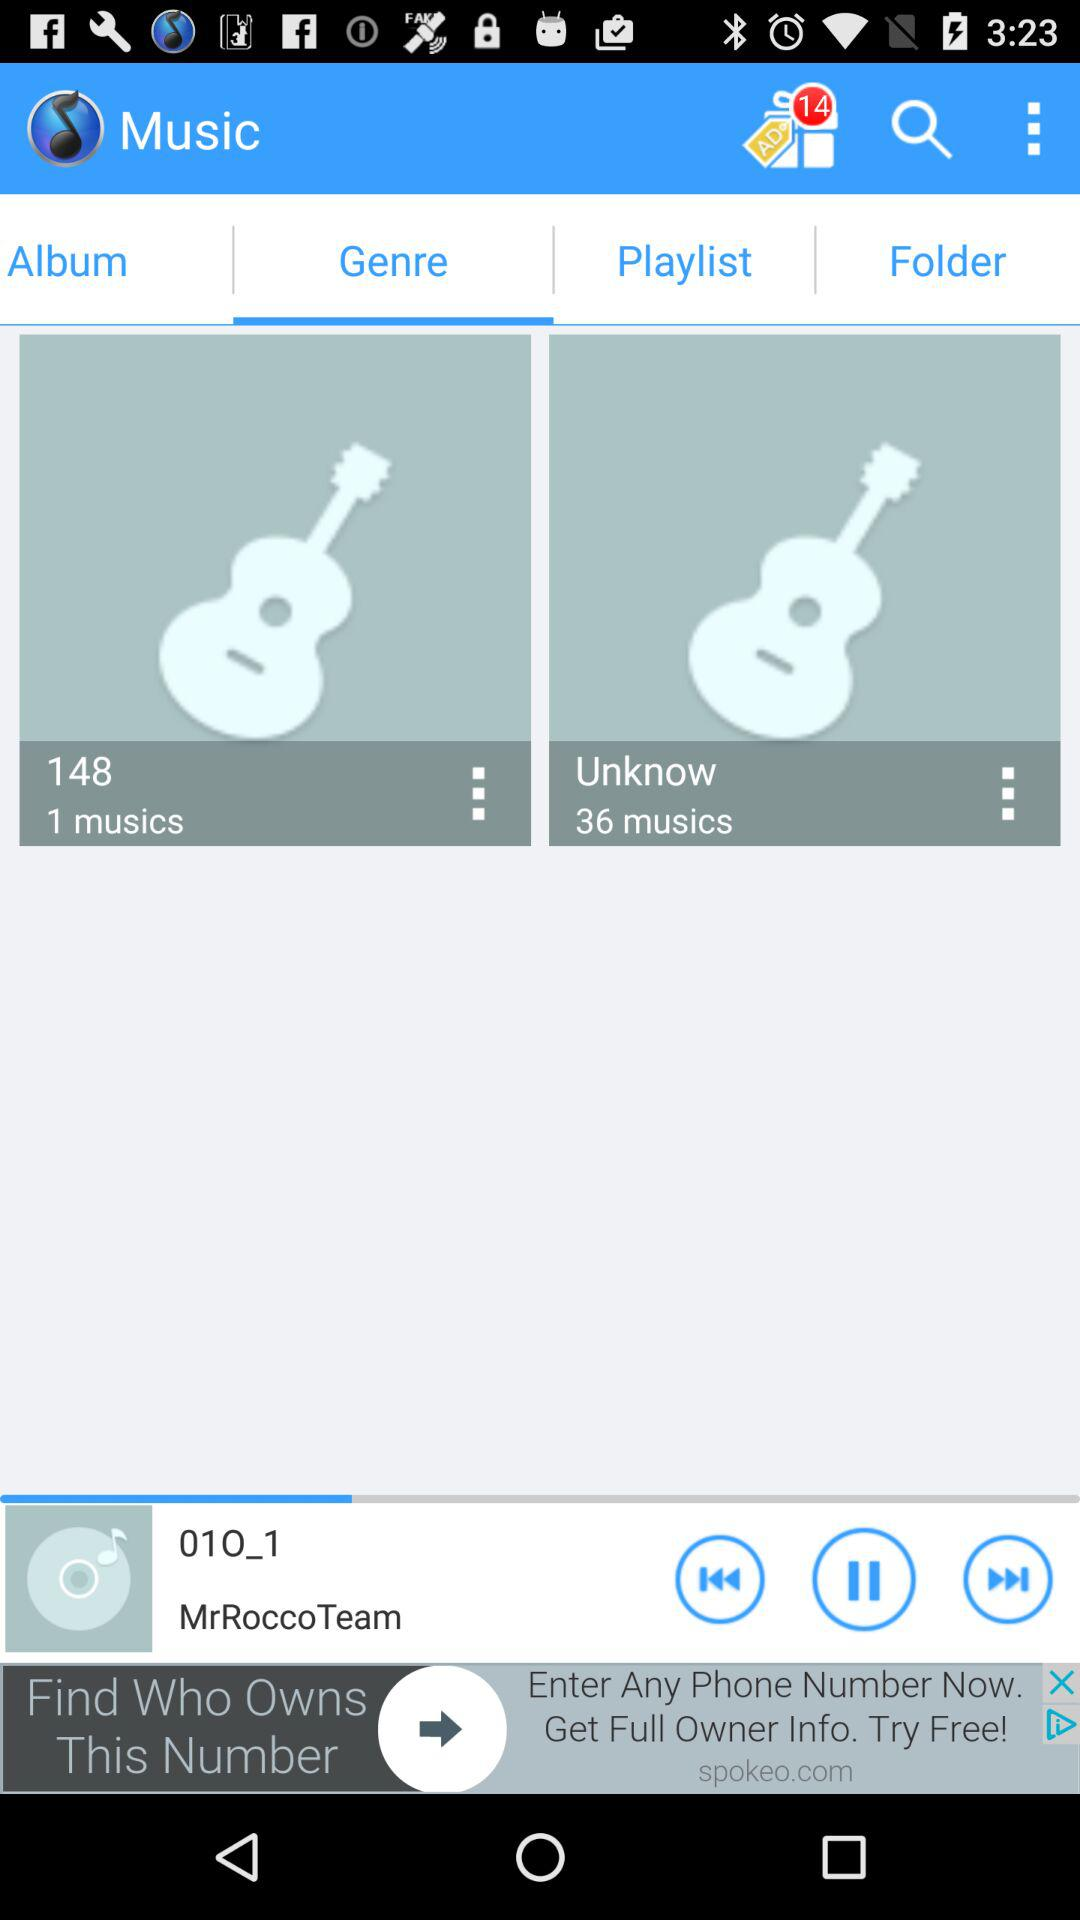Which tab is selected? The selected tab is "Genre". 